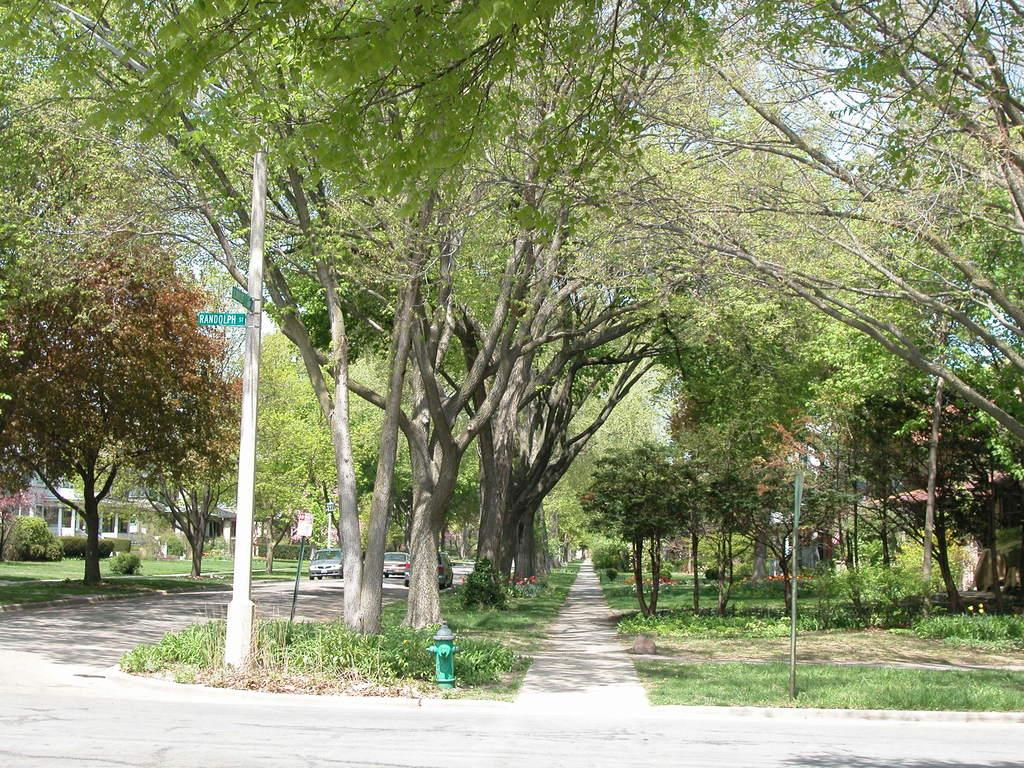What is happening on the road in the image? There are people on the road in the image. What structures can be seen in the image? There are buildings visible in the image. What type of natural vegetation is visible in the image? There are trees visible in the image. What type of scarf is being worn by the people on the road in the image? There is no mention of a scarf being worn by the people on the road in the image. What type of business is being conducted in the buildings visible in the image? There is no information about the type of business being conducted in the buildings visible in the image. 